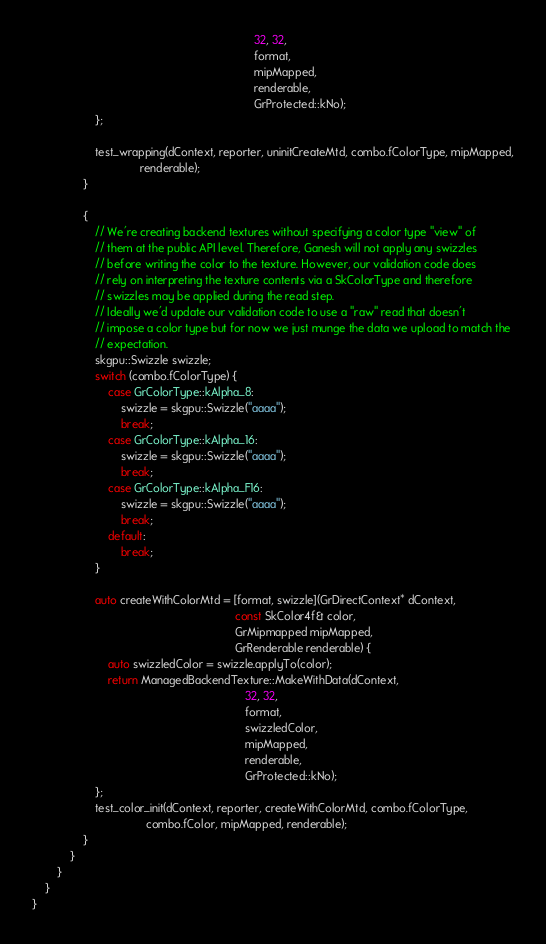Convert code to text. <code><loc_0><loc_0><loc_500><loc_500><_ObjectiveC_>                                                                      32, 32,
                                                                      format,
                                                                      mipMapped,
                                                                      renderable,
                                                                      GrProtected::kNo);
                    };

                    test_wrapping(dContext, reporter, uninitCreateMtd, combo.fColorType, mipMapped,
                                  renderable);
                }

                {
                    // We're creating backend textures without specifying a color type "view" of
                    // them at the public API level. Therefore, Ganesh will not apply any swizzles
                    // before writing the color to the texture. However, our validation code does
                    // rely on interpreting the texture contents via a SkColorType and therefore
                    // swizzles may be applied during the read step.
                    // Ideally we'd update our validation code to use a "raw" read that doesn't
                    // impose a color type but for now we just munge the data we upload to match the
                    // expectation.
                    skgpu::Swizzle swizzle;
                    switch (combo.fColorType) {
                        case GrColorType::kAlpha_8:
                            swizzle = skgpu::Swizzle("aaaa");
                            break;
                        case GrColorType::kAlpha_16:
                            swizzle = skgpu::Swizzle("aaaa");
                            break;
                        case GrColorType::kAlpha_F16:
                            swizzle = skgpu::Swizzle("aaaa");
                            break;
                        default:
                            break;
                    }

                    auto createWithColorMtd = [format, swizzle](GrDirectContext* dContext,
                                                                const SkColor4f& color,
                                                                GrMipmapped mipMapped,
                                                                GrRenderable renderable) {
                        auto swizzledColor = swizzle.applyTo(color);
                        return ManagedBackendTexture::MakeWithData(dContext,
                                                                   32, 32,
                                                                   format,
                                                                   swizzledColor,
                                                                   mipMapped,
                                                                   renderable,
                                                                   GrProtected::kNo);
                    };
                    test_color_init(dContext, reporter, createWithColorMtd, combo.fColorType,
                                    combo.fColor, mipMapped, renderable);
                }
            }
        }
    }
}
</code> 